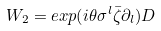Convert formula to latex. <formula><loc_0><loc_0><loc_500><loc_500>W _ { 2 } = e x p ( i \theta \sigma ^ { l } \bar { \zeta } \partial _ { l } ) D</formula> 